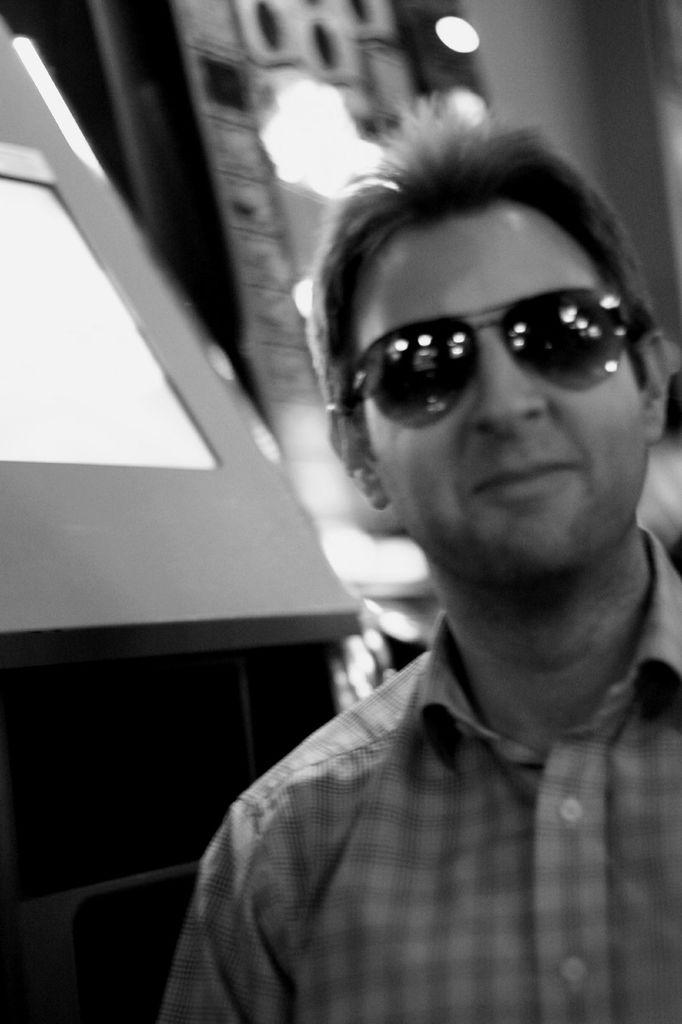Who is present in the image? There is a man in the image. What accessory is the man wearing? The man is wearing glasses. What can be seen in the background of the image? There is a wall and lights visible in the background of the image. What type of silk is being used by the ants in the image? There are no ants or silk present in the image. 